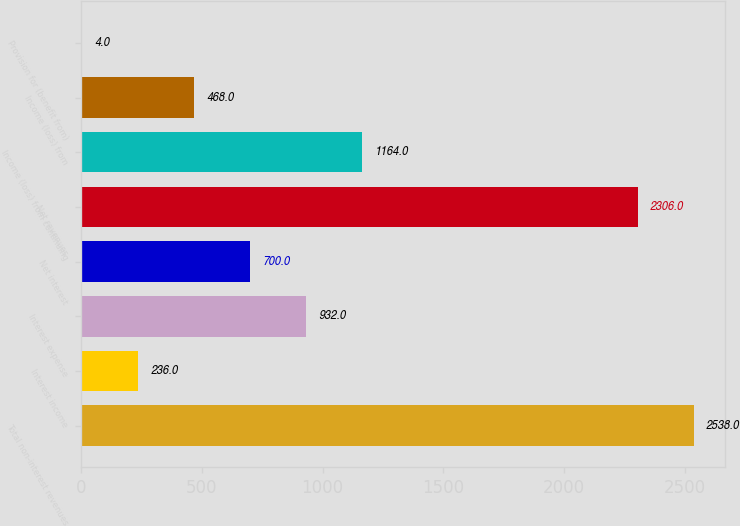<chart> <loc_0><loc_0><loc_500><loc_500><bar_chart><fcel>Total non-interest revenues<fcel>Interest income<fcel>Interest expense<fcel>Net interest<fcel>Net revenues<fcel>Income (loss) from continuing<fcel>Income (loss) from<fcel>Provision for (benefit from)<nl><fcel>2538<fcel>236<fcel>932<fcel>700<fcel>2306<fcel>1164<fcel>468<fcel>4<nl></chart> 